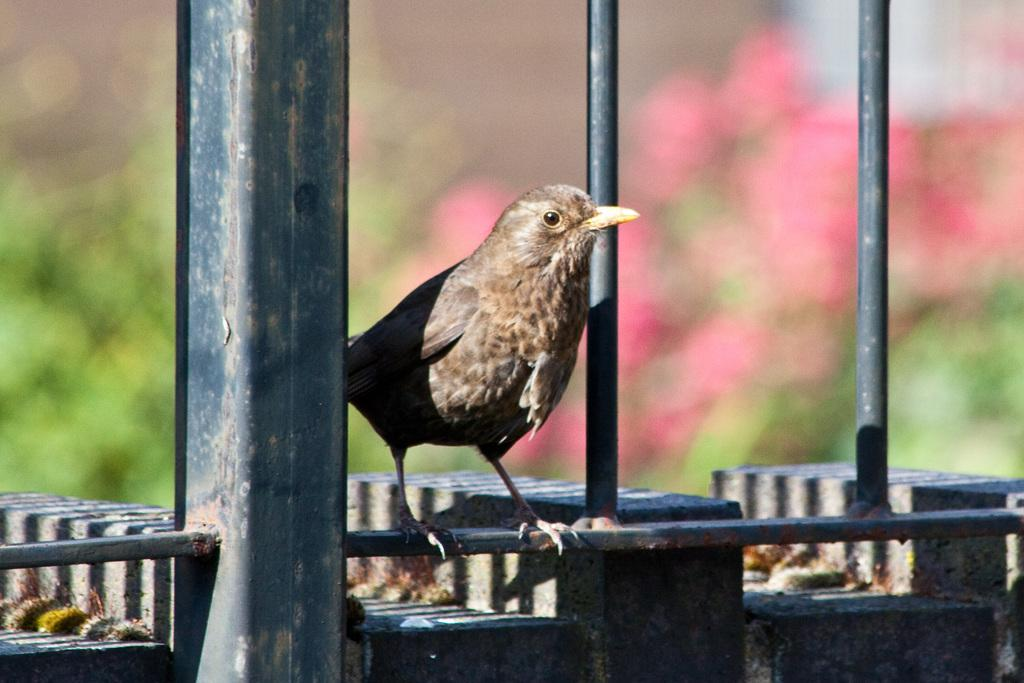What type of animal is in the image? There is a bird in the image. What is the bird standing on? The bird is standing on a rod. What can be seen in the foreground of the image? There is a railing in the foreground of the image. What is visible in the background of the image? There are flowers and trees in the background of the image. How many ladybugs are crawling on the stem of the flower in the image? There are no ladybugs present in the image. What type of legal advice is the bird seeking from the lawyer in the image? There is no lawyer or legal advice present in the image; it features a bird standing on a rod with a railing, flowers, and trees in the background. 